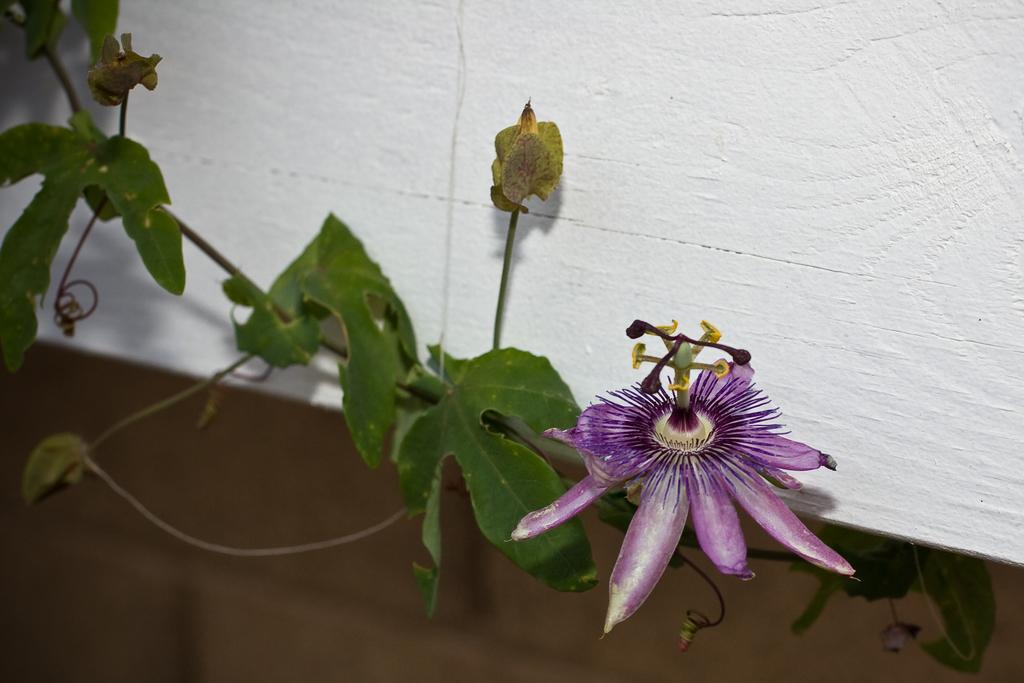What type of plant is visible in the image? There is a plant with a flower in the image. What can be seen in the background of the image? There is a white wall in the background of the image. What type of wall is visible at the bottom of the image? There is a brick wall at the bottom of the image. How many fingers are visible on the plant in the image? There are no fingers visible on the plant in the image, as plants do not have fingers. 